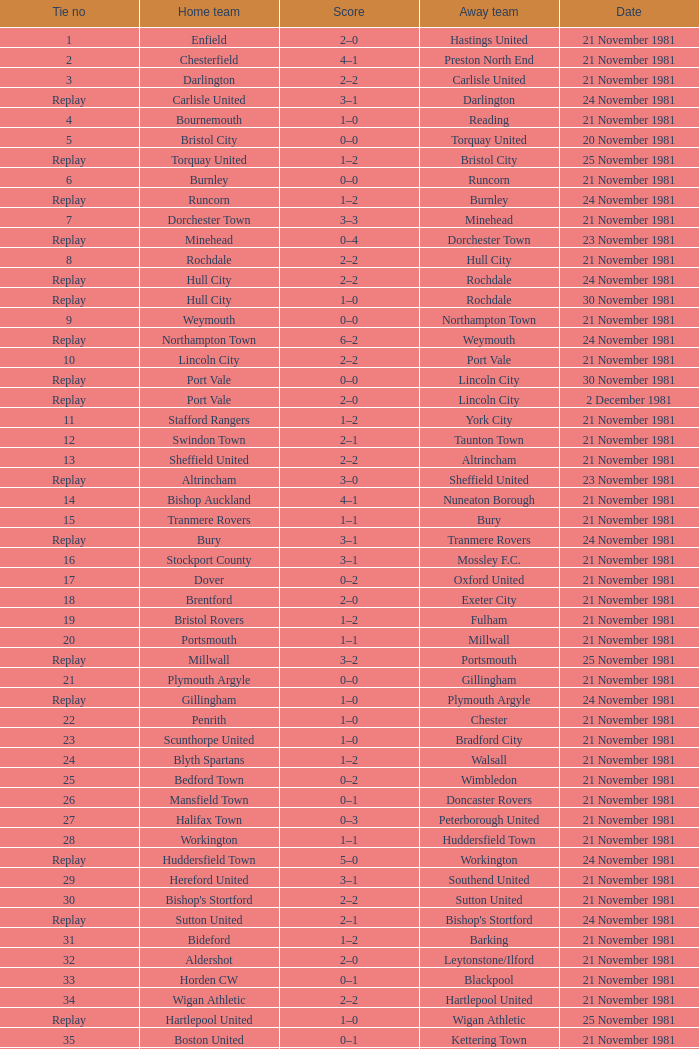What is the numerical tie designation for minehead? Replay. 